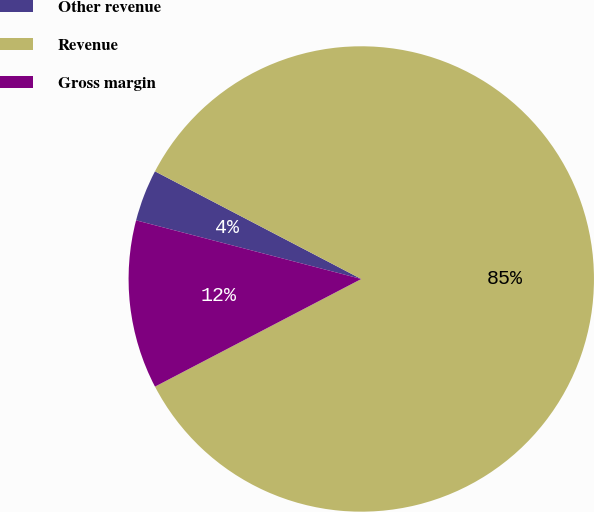Convert chart. <chart><loc_0><loc_0><loc_500><loc_500><pie_chart><fcel>Other revenue<fcel>Revenue<fcel>Gross margin<nl><fcel>3.6%<fcel>84.69%<fcel>11.71%<nl></chart> 